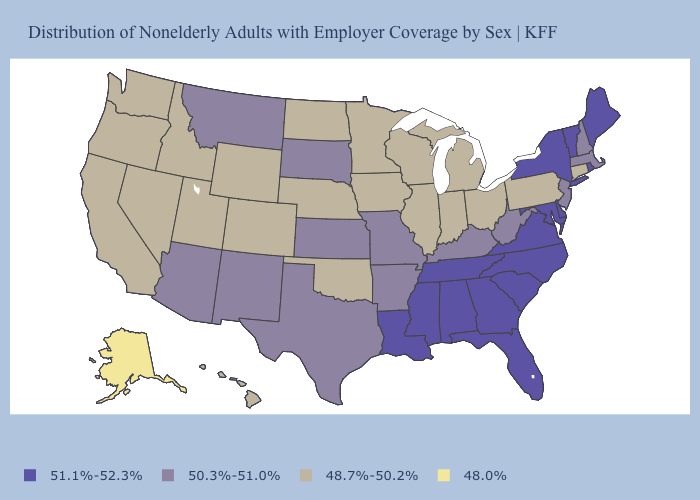What is the value of Montana?
Keep it brief. 50.3%-51.0%. What is the value of Connecticut?
Short answer required. 48.7%-50.2%. Name the states that have a value in the range 48.0%?
Quick response, please. Alaska. Does Rhode Island have the same value as Georgia?
Quick response, please. Yes. What is the highest value in the Northeast ?
Quick response, please. 51.1%-52.3%. Name the states that have a value in the range 48.7%-50.2%?
Answer briefly. California, Colorado, Connecticut, Hawaii, Idaho, Illinois, Indiana, Iowa, Michigan, Minnesota, Nebraska, Nevada, North Dakota, Ohio, Oklahoma, Oregon, Pennsylvania, Utah, Washington, Wisconsin, Wyoming. What is the value of Kansas?
Concise answer only. 50.3%-51.0%. What is the lowest value in the Northeast?
Short answer required. 48.7%-50.2%. Does Maryland have a higher value than Washington?
Short answer required. Yes. Among the states that border Louisiana , which have the highest value?
Answer briefly. Mississippi. Name the states that have a value in the range 51.1%-52.3%?
Short answer required. Alabama, Delaware, Florida, Georgia, Louisiana, Maine, Maryland, Mississippi, New York, North Carolina, Rhode Island, South Carolina, Tennessee, Vermont, Virginia. Name the states that have a value in the range 48.0%?
Concise answer only. Alaska. Among the states that border Illinois , which have the lowest value?
Concise answer only. Indiana, Iowa, Wisconsin. Name the states that have a value in the range 51.1%-52.3%?
Give a very brief answer. Alabama, Delaware, Florida, Georgia, Louisiana, Maine, Maryland, Mississippi, New York, North Carolina, Rhode Island, South Carolina, Tennessee, Vermont, Virginia. What is the value of Utah?
Concise answer only. 48.7%-50.2%. 